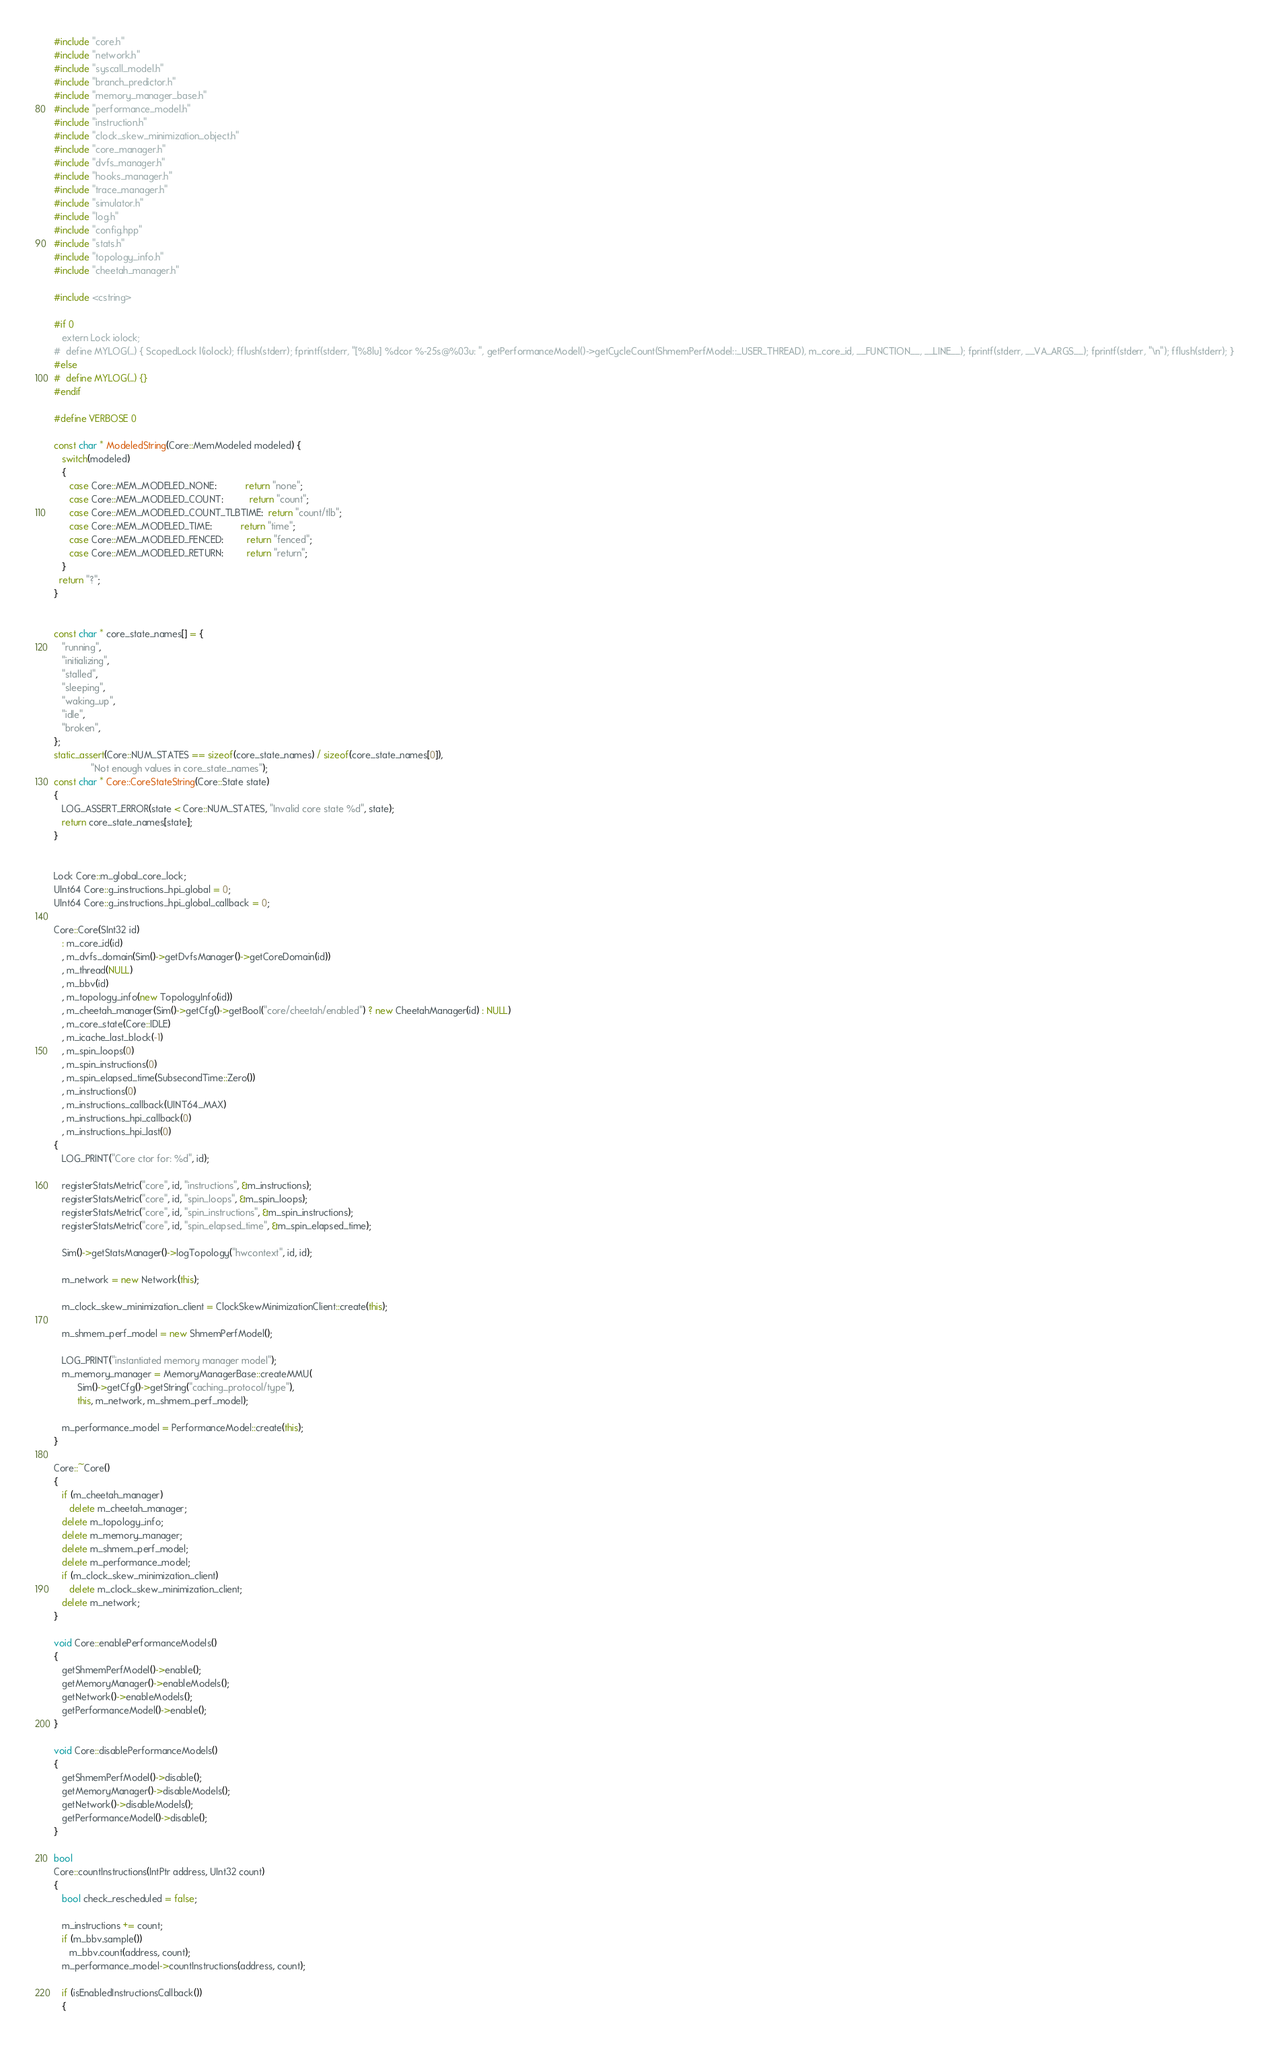<code> <loc_0><loc_0><loc_500><loc_500><_C++_>#include "core.h"
#include "network.h"
#include "syscall_model.h"
#include "branch_predictor.h"
#include "memory_manager_base.h"
#include "performance_model.h"
#include "instruction.h"
#include "clock_skew_minimization_object.h"
#include "core_manager.h"
#include "dvfs_manager.h"
#include "hooks_manager.h"
#include "trace_manager.h"
#include "simulator.h"
#include "log.h"
#include "config.hpp"
#include "stats.h"
#include "topology_info.h"
#include "cheetah_manager.h"

#include <cstring>

#if 0
   extern Lock iolock;
#  define MYLOG(...) { ScopedLock l(iolock); fflush(stderr); fprintf(stderr, "[%8lu] %dcor %-25s@%03u: ", getPerformanceModel()->getCycleCount(ShmemPerfModel::_USER_THREAD), m_core_id, __FUNCTION__, __LINE__); fprintf(stderr, __VA_ARGS__); fprintf(stderr, "\n"); fflush(stderr); }
#else
#  define MYLOG(...) {}
#endif

#define VERBOSE 0

const char * ModeledString(Core::MemModeled modeled) {
   switch(modeled)
   {
      case Core::MEM_MODELED_NONE:           return "none";
      case Core::MEM_MODELED_COUNT:          return "count";
      case Core::MEM_MODELED_COUNT_TLBTIME:  return "count/tlb";
      case Core::MEM_MODELED_TIME:           return "time";
      case Core::MEM_MODELED_FENCED:         return "fenced";
      case Core::MEM_MODELED_RETURN:         return "return";
   }
  return "?";
}


const char * core_state_names[] = {
   "running",
   "initializing",
   "stalled",
   "sleeping",
   "waking_up",
   "idle",
   "broken",
};
static_assert(Core::NUM_STATES == sizeof(core_state_names) / sizeof(core_state_names[0]),
              "Not enough values in core_state_names");
const char * Core::CoreStateString(Core::State state)
{
   LOG_ASSERT_ERROR(state < Core::NUM_STATES, "Invalid core state %d", state);
   return core_state_names[state];
}


Lock Core::m_global_core_lock;
UInt64 Core::g_instructions_hpi_global = 0;
UInt64 Core::g_instructions_hpi_global_callback = 0;

Core::Core(SInt32 id)
   : m_core_id(id)
   , m_dvfs_domain(Sim()->getDvfsManager()->getCoreDomain(id))
   , m_thread(NULL)
   , m_bbv(id)
   , m_topology_info(new TopologyInfo(id))
   , m_cheetah_manager(Sim()->getCfg()->getBool("core/cheetah/enabled") ? new CheetahManager(id) : NULL)
   , m_core_state(Core::IDLE)
   , m_icache_last_block(-1)
   , m_spin_loops(0)
   , m_spin_instructions(0)
   , m_spin_elapsed_time(SubsecondTime::Zero())
   , m_instructions(0)
   , m_instructions_callback(UINT64_MAX)
   , m_instructions_hpi_callback(0)
   , m_instructions_hpi_last(0)
{
   LOG_PRINT("Core ctor for: %d", id);

   registerStatsMetric("core", id, "instructions", &m_instructions);
   registerStatsMetric("core", id, "spin_loops", &m_spin_loops);
   registerStatsMetric("core", id, "spin_instructions", &m_spin_instructions);
   registerStatsMetric("core", id, "spin_elapsed_time", &m_spin_elapsed_time);

   Sim()->getStatsManager()->logTopology("hwcontext", id, id);

   m_network = new Network(this);

   m_clock_skew_minimization_client = ClockSkewMinimizationClient::create(this);

   m_shmem_perf_model = new ShmemPerfModel();

   LOG_PRINT("instantiated memory manager model");
   m_memory_manager = MemoryManagerBase::createMMU(
         Sim()->getCfg()->getString("caching_protocol/type"),
         this, m_network, m_shmem_perf_model);

   m_performance_model = PerformanceModel::create(this);
}

Core::~Core()
{
   if (m_cheetah_manager)
      delete m_cheetah_manager;
   delete m_topology_info;
   delete m_memory_manager;
   delete m_shmem_perf_model;
   delete m_performance_model;
   if (m_clock_skew_minimization_client)
      delete m_clock_skew_minimization_client;
   delete m_network;
}

void Core::enablePerformanceModels()
{
   getShmemPerfModel()->enable();
   getMemoryManager()->enableModels();
   getNetwork()->enableModels();
   getPerformanceModel()->enable();
}

void Core::disablePerformanceModels()
{
   getShmemPerfModel()->disable();
   getMemoryManager()->disableModels();
   getNetwork()->disableModels();
   getPerformanceModel()->disable();
}

bool
Core::countInstructions(IntPtr address, UInt32 count)
{
   bool check_rescheduled = false;

   m_instructions += count;
   if (m_bbv.sample())
      m_bbv.count(address, count);
   m_performance_model->countInstructions(address, count);

   if (isEnabledInstructionsCallback())
   {</code> 